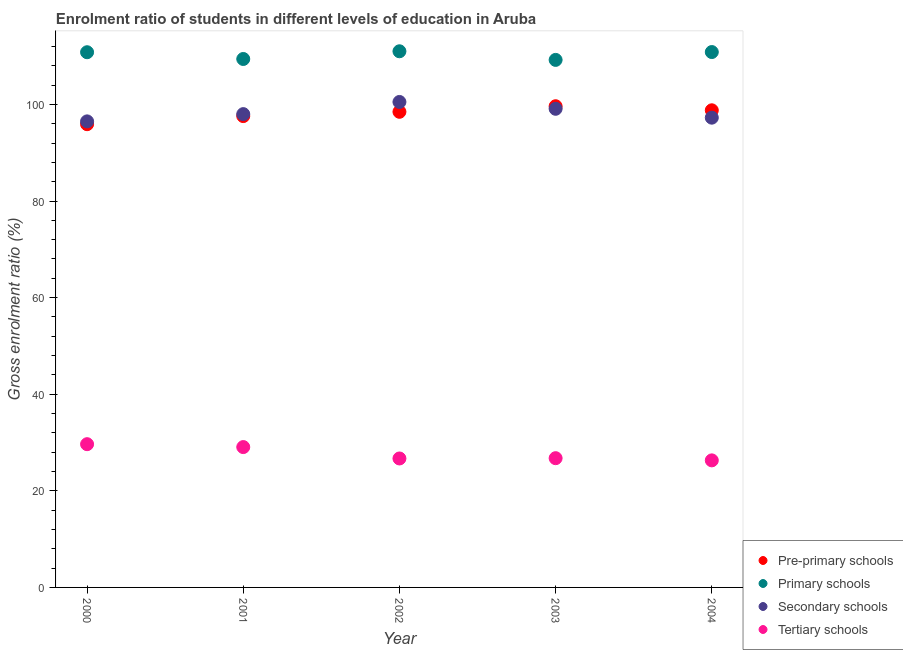How many different coloured dotlines are there?
Provide a short and direct response. 4. What is the gross enrolment ratio in primary schools in 2003?
Ensure brevity in your answer.  109.21. Across all years, what is the maximum gross enrolment ratio in secondary schools?
Offer a terse response. 100.51. Across all years, what is the minimum gross enrolment ratio in primary schools?
Keep it short and to the point. 109.21. What is the total gross enrolment ratio in tertiary schools in the graph?
Your response must be concise. 138.47. What is the difference between the gross enrolment ratio in pre-primary schools in 2000 and that in 2001?
Make the answer very short. -1.68. What is the difference between the gross enrolment ratio in primary schools in 2002 and the gross enrolment ratio in secondary schools in 2004?
Keep it short and to the point. 13.75. What is the average gross enrolment ratio in secondary schools per year?
Offer a terse response. 98.26. In the year 2001, what is the difference between the gross enrolment ratio in primary schools and gross enrolment ratio in pre-primary schools?
Keep it short and to the point. 11.82. In how many years, is the gross enrolment ratio in secondary schools greater than 80 %?
Offer a very short reply. 5. What is the ratio of the gross enrolment ratio in pre-primary schools in 2000 to that in 2002?
Your answer should be very brief. 0.97. Is the gross enrolment ratio in secondary schools in 2002 less than that in 2003?
Keep it short and to the point. No. What is the difference between the highest and the second highest gross enrolment ratio in secondary schools?
Offer a terse response. 1.41. What is the difference between the highest and the lowest gross enrolment ratio in pre-primary schools?
Make the answer very short. 3.72. Is the sum of the gross enrolment ratio in primary schools in 2001 and 2002 greater than the maximum gross enrolment ratio in secondary schools across all years?
Keep it short and to the point. Yes. Is it the case that in every year, the sum of the gross enrolment ratio in pre-primary schools and gross enrolment ratio in primary schools is greater than the gross enrolment ratio in secondary schools?
Give a very brief answer. Yes. Does the gross enrolment ratio in tertiary schools monotonically increase over the years?
Keep it short and to the point. No. How many years are there in the graph?
Offer a very short reply. 5. Does the graph contain grids?
Your response must be concise. No. How are the legend labels stacked?
Give a very brief answer. Vertical. What is the title of the graph?
Ensure brevity in your answer.  Enrolment ratio of students in different levels of education in Aruba. Does "United Kingdom" appear as one of the legend labels in the graph?
Offer a very short reply. No. What is the label or title of the X-axis?
Offer a very short reply. Year. What is the label or title of the Y-axis?
Offer a terse response. Gross enrolment ratio (%). What is the Gross enrolment ratio (%) in Pre-primary schools in 2000?
Ensure brevity in your answer.  95.9. What is the Gross enrolment ratio (%) in Primary schools in 2000?
Your answer should be compact. 110.8. What is the Gross enrolment ratio (%) of Secondary schools in 2000?
Offer a very short reply. 96.49. What is the Gross enrolment ratio (%) in Tertiary schools in 2000?
Provide a short and direct response. 29.66. What is the Gross enrolment ratio (%) of Pre-primary schools in 2001?
Your response must be concise. 97.58. What is the Gross enrolment ratio (%) of Primary schools in 2001?
Provide a short and direct response. 109.4. What is the Gross enrolment ratio (%) in Secondary schools in 2001?
Make the answer very short. 97.99. What is the Gross enrolment ratio (%) in Tertiary schools in 2001?
Provide a short and direct response. 29.06. What is the Gross enrolment ratio (%) of Pre-primary schools in 2002?
Ensure brevity in your answer.  98.47. What is the Gross enrolment ratio (%) of Primary schools in 2002?
Your answer should be very brief. 111. What is the Gross enrolment ratio (%) of Secondary schools in 2002?
Your response must be concise. 100.51. What is the Gross enrolment ratio (%) in Tertiary schools in 2002?
Your answer should be very brief. 26.7. What is the Gross enrolment ratio (%) of Pre-primary schools in 2003?
Your answer should be compact. 99.62. What is the Gross enrolment ratio (%) in Primary schools in 2003?
Provide a short and direct response. 109.21. What is the Gross enrolment ratio (%) of Secondary schools in 2003?
Keep it short and to the point. 99.09. What is the Gross enrolment ratio (%) of Tertiary schools in 2003?
Make the answer very short. 26.76. What is the Gross enrolment ratio (%) in Pre-primary schools in 2004?
Make the answer very short. 98.78. What is the Gross enrolment ratio (%) in Primary schools in 2004?
Your answer should be compact. 110.84. What is the Gross enrolment ratio (%) of Secondary schools in 2004?
Provide a succinct answer. 97.25. What is the Gross enrolment ratio (%) in Tertiary schools in 2004?
Make the answer very short. 26.3. Across all years, what is the maximum Gross enrolment ratio (%) in Pre-primary schools?
Your response must be concise. 99.62. Across all years, what is the maximum Gross enrolment ratio (%) of Primary schools?
Offer a terse response. 111. Across all years, what is the maximum Gross enrolment ratio (%) of Secondary schools?
Your answer should be very brief. 100.51. Across all years, what is the maximum Gross enrolment ratio (%) in Tertiary schools?
Ensure brevity in your answer.  29.66. Across all years, what is the minimum Gross enrolment ratio (%) in Pre-primary schools?
Provide a succinct answer. 95.9. Across all years, what is the minimum Gross enrolment ratio (%) in Primary schools?
Provide a succinct answer. 109.21. Across all years, what is the minimum Gross enrolment ratio (%) in Secondary schools?
Ensure brevity in your answer.  96.49. Across all years, what is the minimum Gross enrolment ratio (%) in Tertiary schools?
Offer a very short reply. 26.3. What is the total Gross enrolment ratio (%) of Pre-primary schools in the graph?
Offer a terse response. 490.36. What is the total Gross enrolment ratio (%) in Primary schools in the graph?
Offer a terse response. 551.26. What is the total Gross enrolment ratio (%) of Secondary schools in the graph?
Provide a short and direct response. 491.32. What is the total Gross enrolment ratio (%) in Tertiary schools in the graph?
Your answer should be compact. 138.47. What is the difference between the Gross enrolment ratio (%) in Pre-primary schools in 2000 and that in 2001?
Ensure brevity in your answer.  -1.68. What is the difference between the Gross enrolment ratio (%) of Primary schools in 2000 and that in 2001?
Make the answer very short. 1.4. What is the difference between the Gross enrolment ratio (%) of Secondary schools in 2000 and that in 2001?
Give a very brief answer. -1.5. What is the difference between the Gross enrolment ratio (%) in Tertiary schools in 2000 and that in 2001?
Ensure brevity in your answer.  0.6. What is the difference between the Gross enrolment ratio (%) in Pre-primary schools in 2000 and that in 2002?
Your answer should be very brief. -2.57. What is the difference between the Gross enrolment ratio (%) in Primary schools in 2000 and that in 2002?
Make the answer very short. -0.2. What is the difference between the Gross enrolment ratio (%) of Secondary schools in 2000 and that in 2002?
Make the answer very short. -4.02. What is the difference between the Gross enrolment ratio (%) of Tertiary schools in 2000 and that in 2002?
Offer a very short reply. 2.96. What is the difference between the Gross enrolment ratio (%) of Pre-primary schools in 2000 and that in 2003?
Ensure brevity in your answer.  -3.72. What is the difference between the Gross enrolment ratio (%) of Primary schools in 2000 and that in 2003?
Provide a succinct answer. 1.59. What is the difference between the Gross enrolment ratio (%) in Secondary schools in 2000 and that in 2003?
Your answer should be very brief. -2.61. What is the difference between the Gross enrolment ratio (%) of Tertiary schools in 2000 and that in 2003?
Your answer should be very brief. 2.9. What is the difference between the Gross enrolment ratio (%) in Pre-primary schools in 2000 and that in 2004?
Offer a terse response. -2.88. What is the difference between the Gross enrolment ratio (%) of Primary schools in 2000 and that in 2004?
Give a very brief answer. -0.04. What is the difference between the Gross enrolment ratio (%) of Secondary schools in 2000 and that in 2004?
Make the answer very short. -0.77. What is the difference between the Gross enrolment ratio (%) of Tertiary schools in 2000 and that in 2004?
Ensure brevity in your answer.  3.35. What is the difference between the Gross enrolment ratio (%) in Pre-primary schools in 2001 and that in 2002?
Your answer should be very brief. -0.89. What is the difference between the Gross enrolment ratio (%) of Primary schools in 2001 and that in 2002?
Provide a succinct answer. -1.6. What is the difference between the Gross enrolment ratio (%) in Secondary schools in 2001 and that in 2002?
Keep it short and to the point. -2.52. What is the difference between the Gross enrolment ratio (%) of Tertiary schools in 2001 and that in 2002?
Your answer should be very brief. 2.36. What is the difference between the Gross enrolment ratio (%) of Pre-primary schools in 2001 and that in 2003?
Keep it short and to the point. -2.04. What is the difference between the Gross enrolment ratio (%) of Primary schools in 2001 and that in 2003?
Your response must be concise. 0.19. What is the difference between the Gross enrolment ratio (%) in Secondary schools in 2001 and that in 2003?
Offer a terse response. -1.1. What is the difference between the Gross enrolment ratio (%) of Tertiary schools in 2001 and that in 2003?
Provide a short and direct response. 2.3. What is the difference between the Gross enrolment ratio (%) of Pre-primary schools in 2001 and that in 2004?
Your response must be concise. -1.2. What is the difference between the Gross enrolment ratio (%) of Primary schools in 2001 and that in 2004?
Offer a very short reply. -1.44. What is the difference between the Gross enrolment ratio (%) in Secondary schools in 2001 and that in 2004?
Your response must be concise. 0.74. What is the difference between the Gross enrolment ratio (%) in Tertiary schools in 2001 and that in 2004?
Offer a terse response. 2.75. What is the difference between the Gross enrolment ratio (%) of Pre-primary schools in 2002 and that in 2003?
Give a very brief answer. -1.15. What is the difference between the Gross enrolment ratio (%) in Primary schools in 2002 and that in 2003?
Keep it short and to the point. 1.78. What is the difference between the Gross enrolment ratio (%) in Secondary schools in 2002 and that in 2003?
Give a very brief answer. 1.41. What is the difference between the Gross enrolment ratio (%) in Tertiary schools in 2002 and that in 2003?
Offer a terse response. -0.06. What is the difference between the Gross enrolment ratio (%) of Pre-primary schools in 2002 and that in 2004?
Provide a short and direct response. -0.31. What is the difference between the Gross enrolment ratio (%) in Primary schools in 2002 and that in 2004?
Provide a short and direct response. 0.16. What is the difference between the Gross enrolment ratio (%) of Secondary schools in 2002 and that in 2004?
Your response must be concise. 3.25. What is the difference between the Gross enrolment ratio (%) of Tertiary schools in 2002 and that in 2004?
Keep it short and to the point. 0.39. What is the difference between the Gross enrolment ratio (%) in Pre-primary schools in 2003 and that in 2004?
Your answer should be compact. 0.84. What is the difference between the Gross enrolment ratio (%) in Primary schools in 2003 and that in 2004?
Your answer should be compact. -1.62. What is the difference between the Gross enrolment ratio (%) in Secondary schools in 2003 and that in 2004?
Offer a terse response. 1.84. What is the difference between the Gross enrolment ratio (%) of Tertiary schools in 2003 and that in 2004?
Provide a short and direct response. 0.45. What is the difference between the Gross enrolment ratio (%) in Pre-primary schools in 2000 and the Gross enrolment ratio (%) in Primary schools in 2001?
Ensure brevity in your answer.  -13.5. What is the difference between the Gross enrolment ratio (%) of Pre-primary schools in 2000 and the Gross enrolment ratio (%) of Secondary schools in 2001?
Ensure brevity in your answer.  -2.08. What is the difference between the Gross enrolment ratio (%) of Pre-primary schools in 2000 and the Gross enrolment ratio (%) of Tertiary schools in 2001?
Give a very brief answer. 66.85. What is the difference between the Gross enrolment ratio (%) of Primary schools in 2000 and the Gross enrolment ratio (%) of Secondary schools in 2001?
Ensure brevity in your answer.  12.81. What is the difference between the Gross enrolment ratio (%) of Primary schools in 2000 and the Gross enrolment ratio (%) of Tertiary schools in 2001?
Ensure brevity in your answer.  81.75. What is the difference between the Gross enrolment ratio (%) of Secondary schools in 2000 and the Gross enrolment ratio (%) of Tertiary schools in 2001?
Offer a terse response. 67.43. What is the difference between the Gross enrolment ratio (%) in Pre-primary schools in 2000 and the Gross enrolment ratio (%) in Primary schools in 2002?
Your response must be concise. -15.1. What is the difference between the Gross enrolment ratio (%) in Pre-primary schools in 2000 and the Gross enrolment ratio (%) in Secondary schools in 2002?
Your response must be concise. -4.6. What is the difference between the Gross enrolment ratio (%) in Pre-primary schools in 2000 and the Gross enrolment ratio (%) in Tertiary schools in 2002?
Offer a terse response. 69.21. What is the difference between the Gross enrolment ratio (%) of Primary schools in 2000 and the Gross enrolment ratio (%) of Secondary schools in 2002?
Offer a terse response. 10.3. What is the difference between the Gross enrolment ratio (%) in Primary schools in 2000 and the Gross enrolment ratio (%) in Tertiary schools in 2002?
Provide a short and direct response. 84.1. What is the difference between the Gross enrolment ratio (%) in Secondary schools in 2000 and the Gross enrolment ratio (%) in Tertiary schools in 2002?
Offer a very short reply. 69.79. What is the difference between the Gross enrolment ratio (%) of Pre-primary schools in 2000 and the Gross enrolment ratio (%) of Primary schools in 2003?
Offer a terse response. -13.31. What is the difference between the Gross enrolment ratio (%) of Pre-primary schools in 2000 and the Gross enrolment ratio (%) of Secondary schools in 2003?
Provide a succinct answer. -3.19. What is the difference between the Gross enrolment ratio (%) in Pre-primary schools in 2000 and the Gross enrolment ratio (%) in Tertiary schools in 2003?
Give a very brief answer. 69.15. What is the difference between the Gross enrolment ratio (%) of Primary schools in 2000 and the Gross enrolment ratio (%) of Secondary schools in 2003?
Your response must be concise. 11.71. What is the difference between the Gross enrolment ratio (%) in Primary schools in 2000 and the Gross enrolment ratio (%) in Tertiary schools in 2003?
Your answer should be very brief. 84.05. What is the difference between the Gross enrolment ratio (%) of Secondary schools in 2000 and the Gross enrolment ratio (%) of Tertiary schools in 2003?
Ensure brevity in your answer.  69.73. What is the difference between the Gross enrolment ratio (%) in Pre-primary schools in 2000 and the Gross enrolment ratio (%) in Primary schools in 2004?
Make the answer very short. -14.94. What is the difference between the Gross enrolment ratio (%) in Pre-primary schools in 2000 and the Gross enrolment ratio (%) in Secondary schools in 2004?
Ensure brevity in your answer.  -1.35. What is the difference between the Gross enrolment ratio (%) in Pre-primary schools in 2000 and the Gross enrolment ratio (%) in Tertiary schools in 2004?
Give a very brief answer. 69.6. What is the difference between the Gross enrolment ratio (%) of Primary schools in 2000 and the Gross enrolment ratio (%) of Secondary schools in 2004?
Your response must be concise. 13.55. What is the difference between the Gross enrolment ratio (%) in Primary schools in 2000 and the Gross enrolment ratio (%) in Tertiary schools in 2004?
Your response must be concise. 84.5. What is the difference between the Gross enrolment ratio (%) in Secondary schools in 2000 and the Gross enrolment ratio (%) in Tertiary schools in 2004?
Provide a short and direct response. 70.18. What is the difference between the Gross enrolment ratio (%) of Pre-primary schools in 2001 and the Gross enrolment ratio (%) of Primary schools in 2002?
Offer a very short reply. -13.41. What is the difference between the Gross enrolment ratio (%) in Pre-primary schools in 2001 and the Gross enrolment ratio (%) in Secondary schools in 2002?
Provide a short and direct response. -2.92. What is the difference between the Gross enrolment ratio (%) in Pre-primary schools in 2001 and the Gross enrolment ratio (%) in Tertiary schools in 2002?
Your answer should be compact. 70.89. What is the difference between the Gross enrolment ratio (%) in Primary schools in 2001 and the Gross enrolment ratio (%) in Secondary schools in 2002?
Give a very brief answer. 8.9. What is the difference between the Gross enrolment ratio (%) in Primary schools in 2001 and the Gross enrolment ratio (%) in Tertiary schools in 2002?
Your answer should be very brief. 82.7. What is the difference between the Gross enrolment ratio (%) in Secondary schools in 2001 and the Gross enrolment ratio (%) in Tertiary schools in 2002?
Offer a terse response. 71.29. What is the difference between the Gross enrolment ratio (%) of Pre-primary schools in 2001 and the Gross enrolment ratio (%) of Primary schools in 2003?
Provide a short and direct response. -11.63. What is the difference between the Gross enrolment ratio (%) of Pre-primary schools in 2001 and the Gross enrolment ratio (%) of Secondary schools in 2003?
Provide a succinct answer. -1.51. What is the difference between the Gross enrolment ratio (%) of Pre-primary schools in 2001 and the Gross enrolment ratio (%) of Tertiary schools in 2003?
Offer a terse response. 70.83. What is the difference between the Gross enrolment ratio (%) of Primary schools in 2001 and the Gross enrolment ratio (%) of Secondary schools in 2003?
Keep it short and to the point. 10.31. What is the difference between the Gross enrolment ratio (%) in Primary schools in 2001 and the Gross enrolment ratio (%) in Tertiary schools in 2003?
Provide a short and direct response. 82.65. What is the difference between the Gross enrolment ratio (%) in Secondary schools in 2001 and the Gross enrolment ratio (%) in Tertiary schools in 2003?
Give a very brief answer. 71.23. What is the difference between the Gross enrolment ratio (%) of Pre-primary schools in 2001 and the Gross enrolment ratio (%) of Primary schools in 2004?
Your answer should be very brief. -13.26. What is the difference between the Gross enrolment ratio (%) in Pre-primary schools in 2001 and the Gross enrolment ratio (%) in Secondary schools in 2004?
Keep it short and to the point. 0.33. What is the difference between the Gross enrolment ratio (%) of Pre-primary schools in 2001 and the Gross enrolment ratio (%) of Tertiary schools in 2004?
Offer a terse response. 71.28. What is the difference between the Gross enrolment ratio (%) in Primary schools in 2001 and the Gross enrolment ratio (%) in Secondary schools in 2004?
Your answer should be very brief. 12.15. What is the difference between the Gross enrolment ratio (%) of Primary schools in 2001 and the Gross enrolment ratio (%) of Tertiary schools in 2004?
Your answer should be very brief. 83.1. What is the difference between the Gross enrolment ratio (%) of Secondary schools in 2001 and the Gross enrolment ratio (%) of Tertiary schools in 2004?
Ensure brevity in your answer.  71.68. What is the difference between the Gross enrolment ratio (%) in Pre-primary schools in 2002 and the Gross enrolment ratio (%) in Primary schools in 2003?
Keep it short and to the point. -10.74. What is the difference between the Gross enrolment ratio (%) in Pre-primary schools in 2002 and the Gross enrolment ratio (%) in Secondary schools in 2003?
Your answer should be very brief. -0.62. What is the difference between the Gross enrolment ratio (%) in Pre-primary schools in 2002 and the Gross enrolment ratio (%) in Tertiary schools in 2003?
Provide a succinct answer. 71.71. What is the difference between the Gross enrolment ratio (%) in Primary schools in 2002 and the Gross enrolment ratio (%) in Secondary schools in 2003?
Provide a succinct answer. 11.91. What is the difference between the Gross enrolment ratio (%) of Primary schools in 2002 and the Gross enrolment ratio (%) of Tertiary schools in 2003?
Provide a succinct answer. 84.24. What is the difference between the Gross enrolment ratio (%) of Secondary schools in 2002 and the Gross enrolment ratio (%) of Tertiary schools in 2003?
Ensure brevity in your answer.  73.75. What is the difference between the Gross enrolment ratio (%) of Pre-primary schools in 2002 and the Gross enrolment ratio (%) of Primary schools in 2004?
Offer a terse response. -12.37. What is the difference between the Gross enrolment ratio (%) of Pre-primary schools in 2002 and the Gross enrolment ratio (%) of Secondary schools in 2004?
Ensure brevity in your answer.  1.22. What is the difference between the Gross enrolment ratio (%) of Pre-primary schools in 2002 and the Gross enrolment ratio (%) of Tertiary schools in 2004?
Offer a very short reply. 72.17. What is the difference between the Gross enrolment ratio (%) in Primary schools in 2002 and the Gross enrolment ratio (%) in Secondary schools in 2004?
Make the answer very short. 13.75. What is the difference between the Gross enrolment ratio (%) of Primary schools in 2002 and the Gross enrolment ratio (%) of Tertiary schools in 2004?
Your answer should be very brief. 84.69. What is the difference between the Gross enrolment ratio (%) in Secondary schools in 2002 and the Gross enrolment ratio (%) in Tertiary schools in 2004?
Keep it short and to the point. 74.2. What is the difference between the Gross enrolment ratio (%) of Pre-primary schools in 2003 and the Gross enrolment ratio (%) of Primary schools in 2004?
Offer a terse response. -11.22. What is the difference between the Gross enrolment ratio (%) in Pre-primary schools in 2003 and the Gross enrolment ratio (%) in Secondary schools in 2004?
Offer a very short reply. 2.37. What is the difference between the Gross enrolment ratio (%) of Pre-primary schools in 2003 and the Gross enrolment ratio (%) of Tertiary schools in 2004?
Make the answer very short. 73.32. What is the difference between the Gross enrolment ratio (%) of Primary schools in 2003 and the Gross enrolment ratio (%) of Secondary schools in 2004?
Your answer should be compact. 11.96. What is the difference between the Gross enrolment ratio (%) of Primary schools in 2003 and the Gross enrolment ratio (%) of Tertiary schools in 2004?
Offer a terse response. 82.91. What is the difference between the Gross enrolment ratio (%) in Secondary schools in 2003 and the Gross enrolment ratio (%) in Tertiary schools in 2004?
Give a very brief answer. 72.79. What is the average Gross enrolment ratio (%) in Pre-primary schools per year?
Offer a terse response. 98.07. What is the average Gross enrolment ratio (%) in Primary schools per year?
Keep it short and to the point. 110.25. What is the average Gross enrolment ratio (%) of Secondary schools per year?
Give a very brief answer. 98.26. What is the average Gross enrolment ratio (%) in Tertiary schools per year?
Make the answer very short. 27.69. In the year 2000, what is the difference between the Gross enrolment ratio (%) in Pre-primary schools and Gross enrolment ratio (%) in Primary schools?
Provide a short and direct response. -14.9. In the year 2000, what is the difference between the Gross enrolment ratio (%) in Pre-primary schools and Gross enrolment ratio (%) in Secondary schools?
Offer a very short reply. -0.58. In the year 2000, what is the difference between the Gross enrolment ratio (%) of Pre-primary schools and Gross enrolment ratio (%) of Tertiary schools?
Offer a terse response. 66.25. In the year 2000, what is the difference between the Gross enrolment ratio (%) in Primary schools and Gross enrolment ratio (%) in Secondary schools?
Give a very brief answer. 14.32. In the year 2000, what is the difference between the Gross enrolment ratio (%) in Primary schools and Gross enrolment ratio (%) in Tertiary schools?
Provide a succinct answer. 81.15. In the year 2000, what is the difference between the Gross enrolment ratio (%) of Secondary schools and Gross enrolment ratio (%) of Tertiary schools?
Offer a terse response. 66.83. In the year 2001, what is the difference between the Gross enrolment ratio (%) of Pre-primary schools and Gross enrolment ratio (%) of Primary schools?
Make the answer very short. -11.82. In the year 2001, what is the difference between the Gross enrolment ratio (%) of Pre-primary schools and Gross enrolment ratio (%) of Secondary schools?
Offer a very short reply. -0.4. In the year 2001, what is the difference between the Gross enrolment ratio (%) in Pre-primary schools and Gross enrolment ratio (%) in Tertiary schools?
Offer a very short reply. 68.53. In the year 2001, what is the difference between the Gross enrolment ratio (%) in Primary schools and Gross enrolment ratio (%) in Secondary schools?
Make the answer very short. 11.42. In the year 2001, what is the difference between the Gross enrolment ratio (%) of Primary schools and Gross enrolment ratio (%) of Tertiary schools?
Provide a short and direct response. 80.35. In the year 2001, what is the difference between the Gross enrolment ratio (%) in Secondary schools and Gross enrolment ratio (%) in Tertiary schools?
Your answer should be compact. 68.93. In the year 2002, what is the difference between the Gross enrolment ratio (%) in Pre-primary schools and Gross enrolment ratio (%) in Primary schools?
Offer a terse response. -12.53. In the year 2002, what is the difference between the Gross enrolment ratio (%) in Pre-primary schools and Gross enrolment ratio (%) in Secondary schools?
Make the answer very short. -2.04. In the year 2002, what is the difference between the Gross enrolment ratio (%) of Pre-primary schools and Gross enrolment ratio (%) of Tertiary schools?
Ensure brevity in your answer.  71.77. In the year 2002, what is the difference between the Gross enrolment ratio (%) in Primary schools and Gross enrolment ratio (%) in Secondary schools?
Your answer should be very brief. 10.49. In the year 2002, what is the difference between the Gross enrolment ratio (%) of Primary schools and Gross enrolment ratio (%) of Tertiary schools?
Make the answer very short. 84.3. In the year 2002, what is the difference between the Gross enrolment ratio (%) in Secondary schools and Gross enrolment ratio (%) in Tertiary schools?
Your answer should be compact. 73.81. In the year 2003, what is the difference between the Gross enrolment ratio (%) of Pre-primary schools and Gross enrolment ratio (%) of Primary schools?
Provide a short and direct response. -9.59. In the year 2003, what is the difference between the Gross enrolment ratio (%) in Pre-primary schools and Gross enrolment ratio (%) in Secondary schools?
Keep it short and to the point. 0.53. In the year 2003, what is the difference between the Gross enrolment ratio (%) in Pre-primary schools and Gross enrolment ratio (%) in Tertiary schools?
Offer a very short reply. 72.87. In the year 2003, what is the difference between the Gross enrolment ratio (%) of Primary schools and Gross enrolment ratio (%) of Secondary schools?
Make the answer very short. 10.12. In the year 2003, what is the difference between the Gross enrolment ratio (%) of Primary schools and Gross enrolment ratio (%) of Tertiary schools?
Ensure brevity in your answer.  82.46. In the year 2003, what is the difference between the Gross enrolment ratio (%) in Secondary schools and Gross enrolment ratio (%) in Tertiary schools?
Your answer should be compact. 72.33. In the year 2004, what is the difference between the Gross enrolment ratio (%) of Pre-primary schools and Gross enrolment ratio (%) of Primary schools?
Provide a succinct answer. -12.06. In the year 2004, what is the difference between the Gross enrolment ratio (%) of Pre-primary schools and Gross enrolment ratio (%) of Secondary schools?
Keep it short and to the point. 1.53. In the year 2004, what is the difference between the Gross enrolment ratio (%) of Pre-primary schools and Gross enrolment ratio (%) of Tertiary schools?
Keep it short and to the point. 72.48. In the year 2004, what is the difference between the Gross enrolment ratio (%) of Primary schools and Gross enrolment ratio (%) of Secondary schools?
Provide a succinct answer. 13.59. In the year 2004, what is the difference between the Gross enrolment ratio (%) of Primary schools and Gross enrolment ratio (%) of Tertiary schools?
Offer a very short reply. 84.53. In the year 2004, what is the difference between the Gross enrolment ratio (%) in Secondary schools and Gross enrolment ratio (%) in Tertiary schools?
Offer a very short reply. 70.95. What is the ratio of the Gross enrolment ratio (%) of Pre-primary schools in 2000 to that in 2001?
Make the answer very short. 0.98. What is the ratio of the Gross enrolment ratio (%) of Primary schools in 2000 to that in 2001?
Keep it short and to the point. 1.01. What is the ratio of the Gross enrolment ratio (%) of Secondary schools in 2000 to that in 2001?
Provide a succinct answer. 0.98. What is the ratio of the Gross enrolment ratio (%) of Tertiary schools in 2000 to that in 2001?
Give a very brief answer. 1.02. What is the ratio of the Gross enrolment ratio (%) in Pre-primary schools in 2000 to that in 2002?
Offer a very short reply. 0.97. What is the ratio of the Gross enrolment ratio (%) in Primary schools in 2000 to that in 2002?
Your response must be concise. 1. What is the ratio of the Gross enrolment ratio (%) of Tertiary schools in 2000 to that in 2002?
Provide a short and direct response. 1.11. What is the ratio of the Gross enrolment ratio (%) in Pre-primary schools in 2000 to that in 2003?
Keep it short and to the point. 0.96. What is the ratio of the Gross enrolment ratio (%) in Primary schools in 2000 to that in 2003?
Give a very brief answer. 1.01. What is the ratio of the Gross enrolment ratio (%) in Secondary schools in 2000 to that in 2003?
Give a very brief answer. 0.97. What is the ratio of the Gross enrolment ratio (%) in Tertiary schools in 2000 to that in 2003?
Provide a succinct answer. 1.11. What is the ratio of the Gross enrolment ratio (%) in Pre-primary schools in 2000 to that in 2004?
Offer a very short reply. 0.97. What is the ratio of the Gross enrolment ratio (%) of Secondary schools in 2000 to that in 2004?
Your answer should be very brief. 0.99. What is the ratio of the Gross enrolment ratio (%) of Tertiary schools in 2000 to that in 2004?
Give a very brief answer. 1.13. What is the ratio of the Gross enrolment ratio (%) in Primary schools in 2001 to that in 2002?
Make the answer very short. 0.99. What is the ratio of the Gross enrolment ratio (%) in Secondary schools in 2001 to that in 2002?
Offer a very short reply. 0.97. What is the ratio of the Gross enrolment ratio (%) of Tertiary schools in 2001 to that in 2002?
Keep it short and to the point. 1.09. What is the ratio of the Gross enrolment ratio (%) of Pre-primary schools in 2001 to that in 2003?
Keep it short and to the point. 0.98. What is the ratio of the Gross enrolment ratio (%) in Primary schools in 2001 to that in 2003?
Your answer should be compact. 1. What is the ratio of the Gross enrolment ratio (%) of Secondary schools in 2001 to that in 2003?
Provide a short and direct response. 0.99. What is the ratio of the Gross enrolment ratio (%) of Tertiary schools in 2001 to that in 2003?
Provide a short and direct response. 1.09. What is the ratio of the Gross enrolment ratio (%) of Pre-primary schools in 2001 to that in 2004?
Provide a short and direct response. 0.99. What is the ratio of the Gross enrolment ratio (%) in Secondary schools in 2001 to that in 2004?
Provide a succinct answer. 1.01. What is the ratio of the Gross enrolment ratio (%) in Tertiary schools in 2001 to that in 2004?
Give a very brief answer. 1.1. What is the ratio of the Gross enrolment ratio (%) of Pre-primary schools in 2002 to that in 2003?
Keep it short and to the point. 0.99. What is the ratio of the Gross enrolment ratio (%) of Primary schools in 2002 to that in 2003?
Keep it short and to the point. 1.02. What is the ratio of the Gross enrolment ratio (%) of Secondary schools in 2002 to that in 2003?
Your answer should be compact. 1.01. What is the ratio of the Gross enrolment ratio (%) in Tertiary schools in 2002 to that in 2003?
Provide a succinct answer. 1. What is the ratio of the Gross enrolment ratio (%) in Pre-primary schools in 2002 to that in 2004?
Keep it short and to the point. 1. What is the ratio of the Gross enrolment ratio (%) in Secondary schools in 2002 to that in 2004?
Your answer should be compact. 1.03. What is the ratio of the Gross enrolment ratio (%) in Tertiary schools in 2002 to that in 2004?
Keep it short and to the point. 1.01. What is the ratio of the Gross enrolment ratio (%) of Pre-primary schools in 2003 to that in 2004?
Your response must be concise. 1.01. What is the ratio of the Gross enrolment ratio (%) of Primary schools in 2003 to that in 2004?
Offer a very short reply. 0.99. What is the ratio of the Gross enrolment ratio (%) of Secondary schools in 2003 to that in 2004?
Offer a very short reply. 1.02. What is the ratio of the Gross enrolment ratio (%) of Tertiary schools in 2003 to that in 2004?
Keep it short and to the point. 1.02. What is the difference between the highest and the second highest Gross enrolment ratio (%) in Pre-primary schools?
Your answer should be compact. 0.84. What is the difference between the highest and the second highest Gross enrolment ratio (%) of Primary schools?
Give a very brief answer. 0.16. What is the difference between the highest and the second highest Gross enrolment ratio (%) of Secondary schools?
Your response must be concise. 1.41. What is the difference between the highest and the second highest Gross enrolment ratio (%) in Tertiary schools?
Give a very brief answer. 0.6. What is the difference between the highest and the lowest Gross enrolment ratio (%) of Pre-primary schools?
Your response must be concise. 3.72. What is the difference between the highest and the lowest Gross enrolment ratio (%) of Primary schools?
Offer a very short reply. 1.78. What is the difference between the highest and the lowest Gross enrolment ratio (%) in Secondary schools?
Give a very brief answer. 4.02. What is the difference between the highest and the lowest Gross enrolment ratio (%) in Tertiary schools?
Keep it short and to the point. 3.35. 